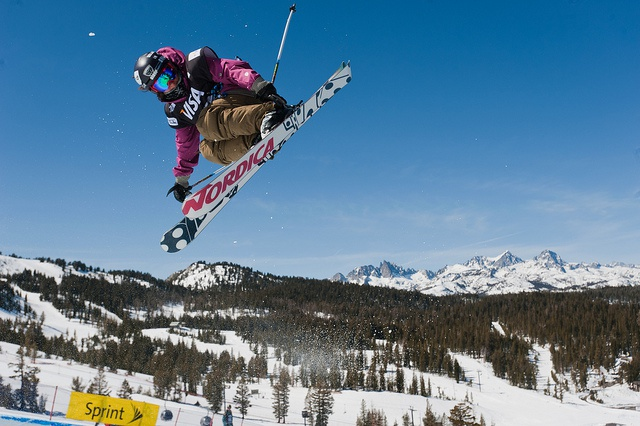Describe the objects in this image and their specific colors. I can see people in blue, black, gray, and maroon tones and skis in blue, darkgray, black, and brown tones in this image. 